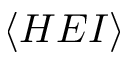<formula> <loc_0><loc_0><loc_500><loc_500>\langle H E I \rangle</formula> 